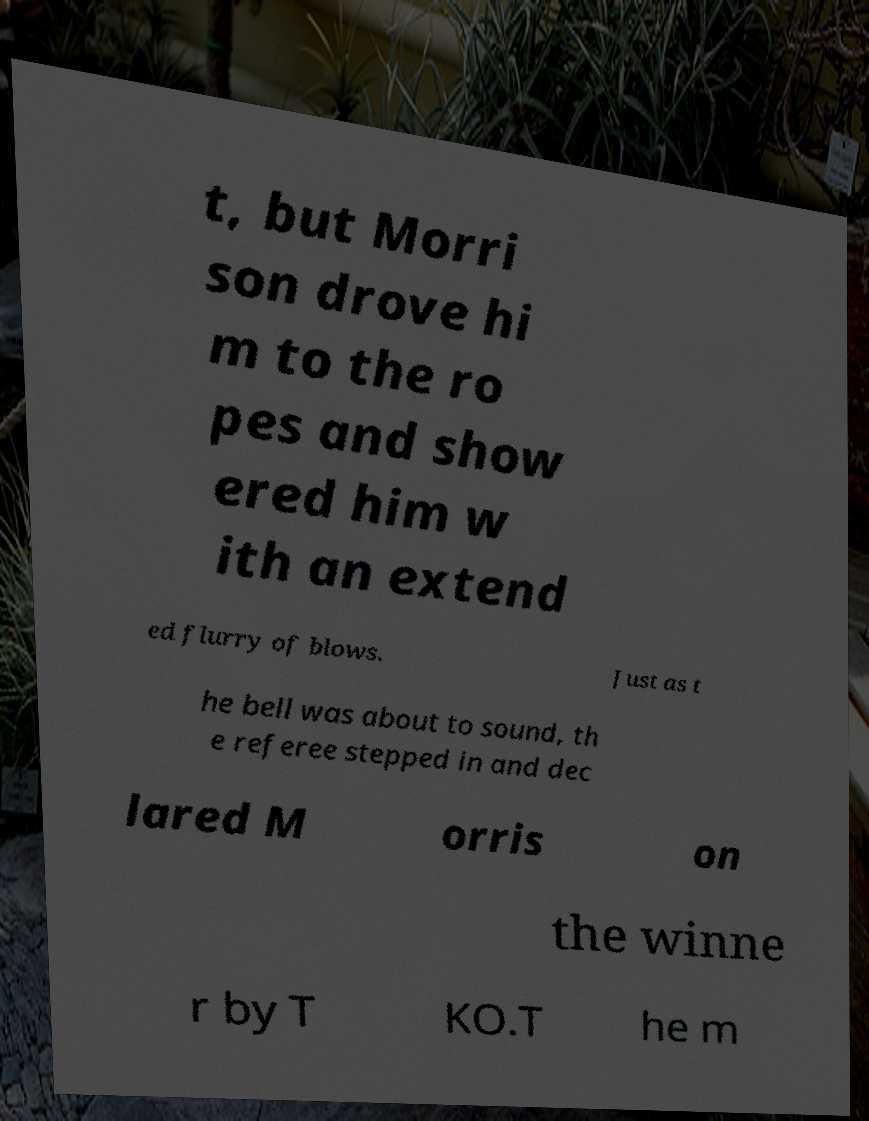Could you assist in decoding the text presented in this image and type it out clearly? t, but Morri son drove hi m to the ro pes and show ered him w ith an extend ed flurry of blows. Just as t he bell was about to sound, th e referee stepped in and dec lared M orris on the winne r by T KO.T he m 